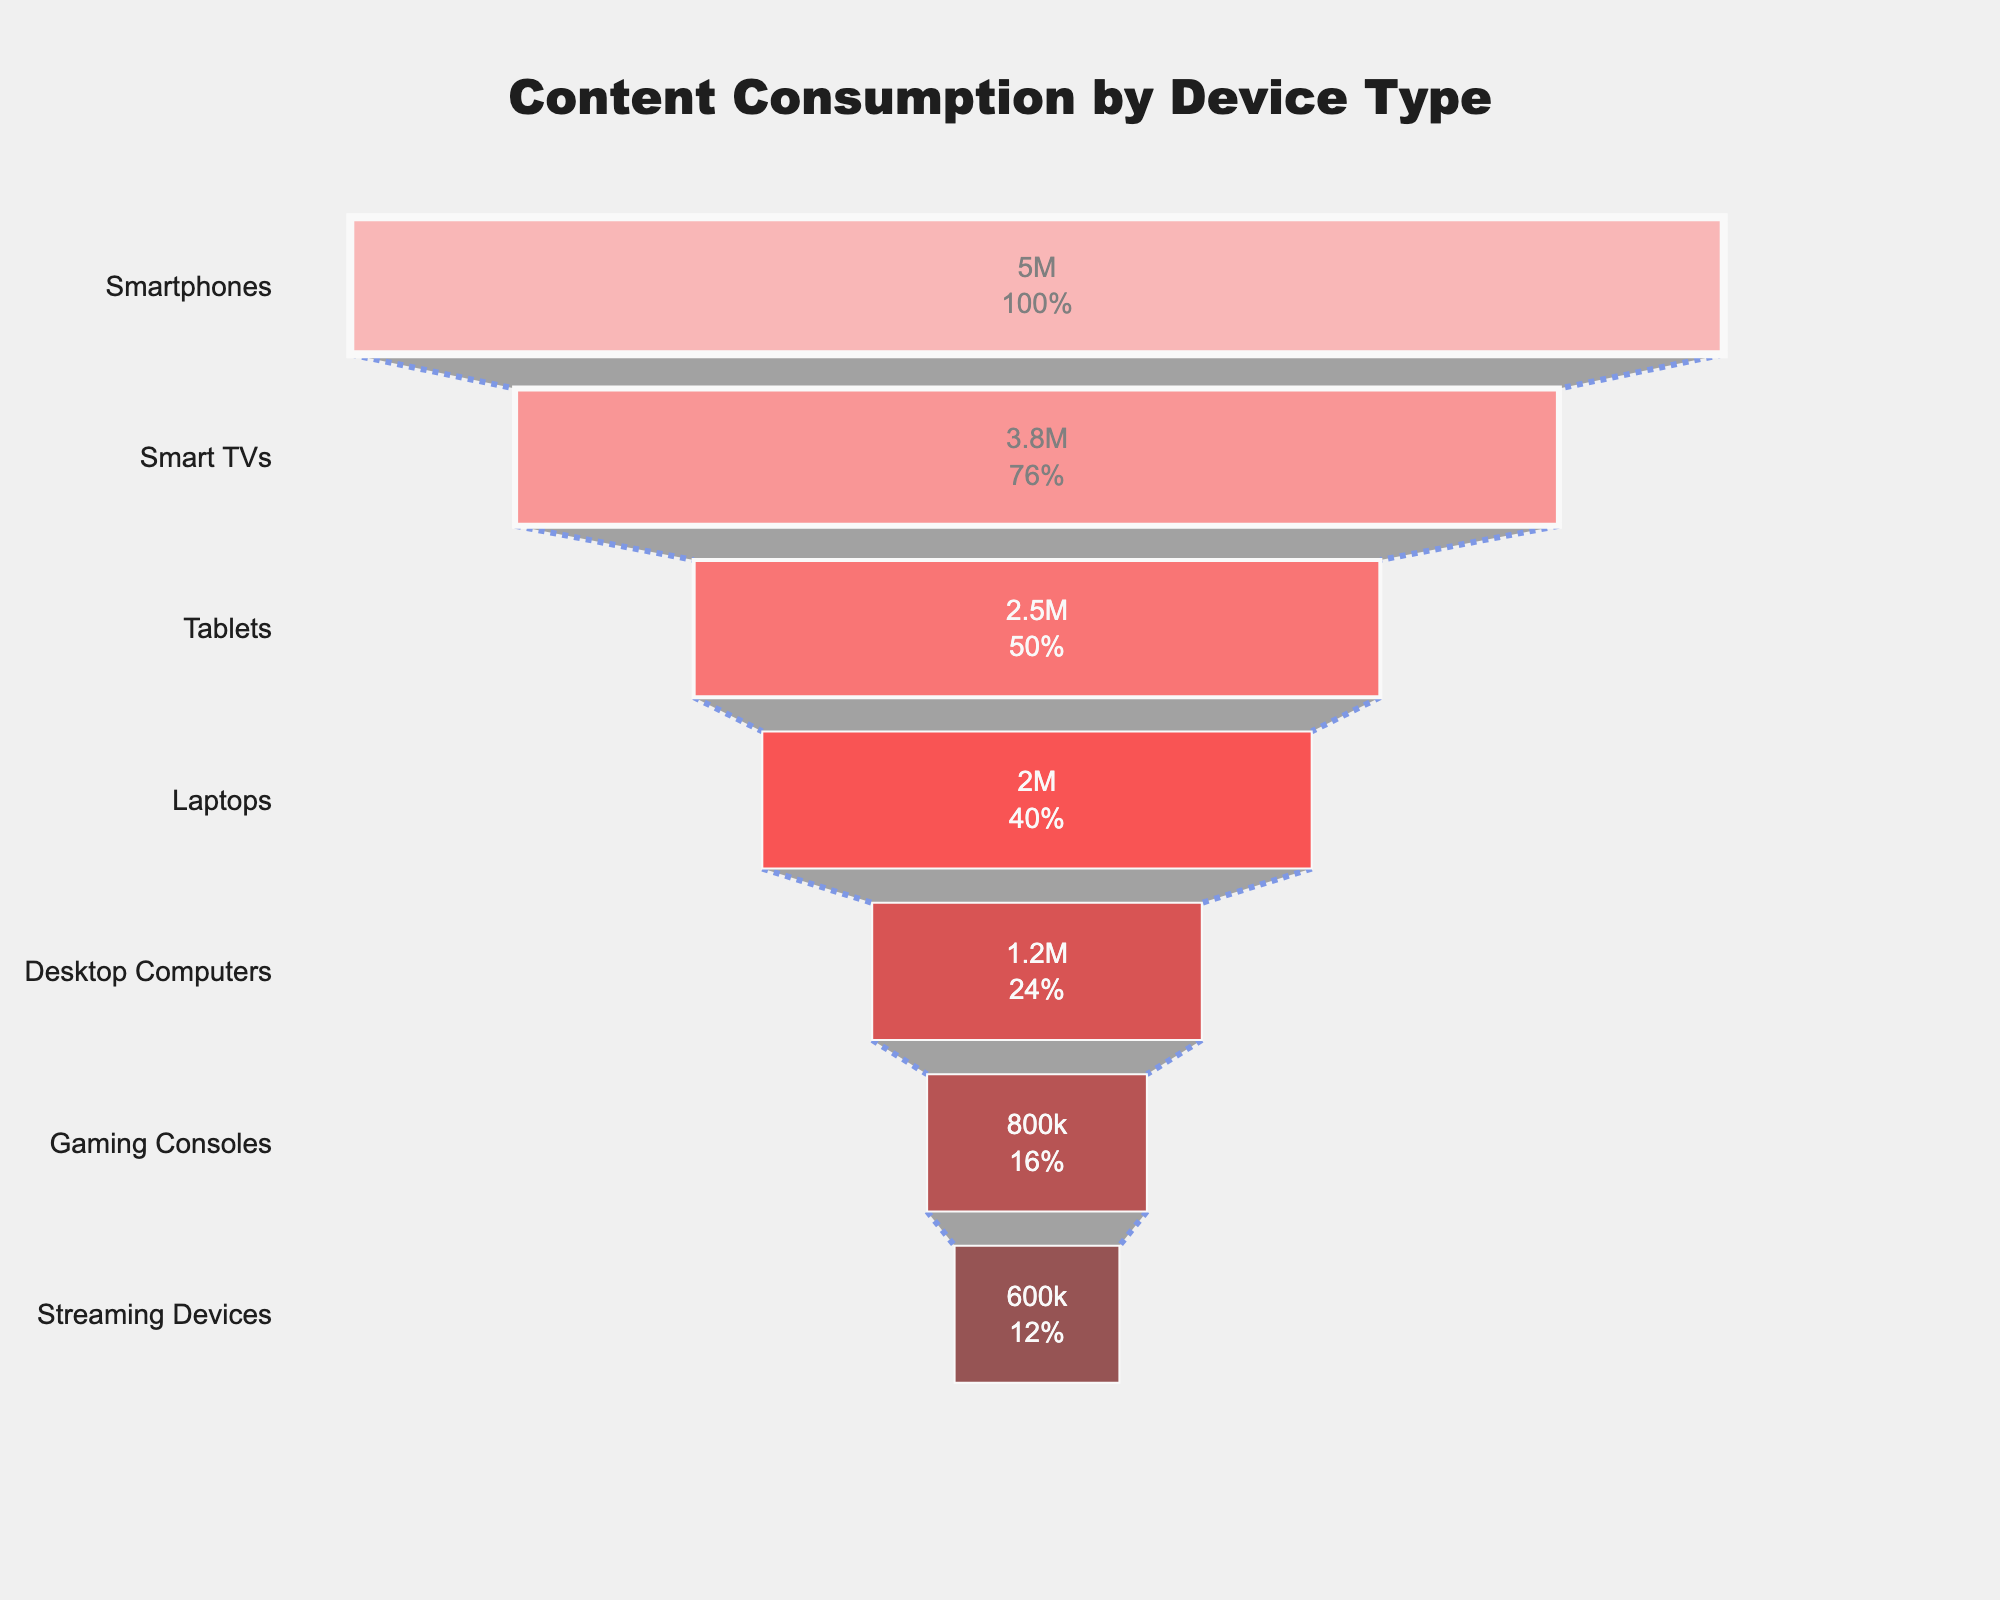What is the title of the funnel chart? The title of the figure is typically displayed at the top of the funnel chart in large, bold text. It provides an immediate context for what the chart is depicting.
Answer: Content Consumption by Device Type Which device has the highest number of users? By examining the funnel chart from top to bottom, you can see which bar is longest, representing the highest number of users.
Answer: Smartphones Which device has the lowest number of users? Look for the shortest bar at the bottom of the funnel chart to find the device with the lowest number of users.
Answer: Streaming Devices How many more users consume content on Smart TVs compared to Tablets? To find this, identify the values for Smart TVs and Tablets, then subtract the number of users of Tablets from the number of users of Smart TVs (3800000 - 2500000).
Answer: 1,300,000 What percentage of the initial audience uses Smartphones to consume content? The funnel chart provides percentage details. The percentage of the initial audience using Smartphones is provided right inside the top bar.
Answer: 100% What is the combined number of users for Laptops and Desktop Computers? Add the number of users for Laptops (2000000) and Desktop Computers (1200000) to get the combined number (2000000 + 1200000).
Answer: 3,200,000 Which two devices together make up more than half of the total users? To find this, calculate the total number of users and then look for any two consecutive devices in the funnel chart that together exceed half of this total. The top two devices are likely candidates.
Answer: Smartphones and Smart TVs How does the user count for Gaming Consoles compare to Streaming Devices? Look at the length of the bars for Gaming Consoles and Streaming Devices, and see which is longer.
Answer: Gaming Consoles have more users What general trend do you observe in the user's preference for devices? Describe the overall flow from the top to the bottom of the funnel chart, noting that it shows a decreasing number of users for each subsequent device type.
Answer: User preference decreases from Smartphones to Streaming Devices What can be inferred about the popularity of Smart TVs compared to Laptops based on the chart? By comparing the lengths of their respective bars in the funnel chart, it's clear that Smart TVs are more popular as they have a longer bar indicating more users than Laptops.
Answer: Smart TVs are more popular 